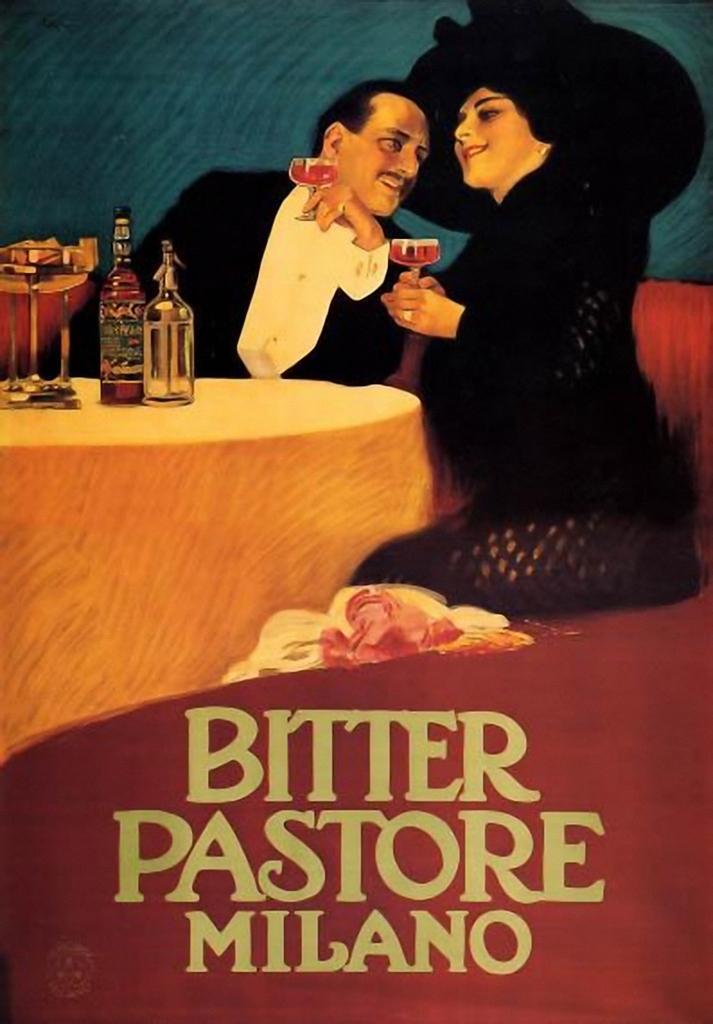Please provide a concise description of this image. This is a poster where woman and man are sitting on the chair holding glass at the table. 